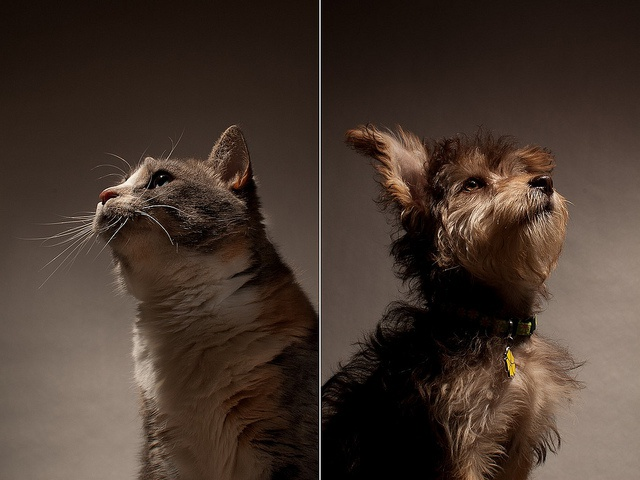Describe the objects in this image and their specific colors. I can see dog in black, maroon, and gray tones and cat in black, gray, and maroon tones in this image. 